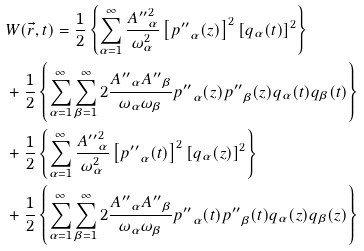<formula> <loc_0><loc_0><loc_500><loc_500>& W ( \vec { r } , t ) = \frac { 1 } { 2 } \left \{ \sum _ { \alpha = 1 } ^ { \infty } \frac { { A ^ { \prime \prime } } _ { \alpha } ^ { 2 } } { \omega _ { \alpha } ^ { 2 } } \left [ { p ^ { \prime \prime } } _ { \alpha } ( z ) \right ] ^ { 2 } \left [ q _ { \alpha } ( t ) \right ] ^ { 2 } \right \} \\ & + \frac { 1 } { 2 } \left \{ \sum _ { \alpha = 1 } ^ { \infty } \sum _ { \beta = 1 } ^ { \infty } 2 \frac { { A ^ { \prime \prime } } _ { \alpha } { A ^ { \prime \prime } } _ { \beta } } { \omega _ { \alpha } \omega _ { \beta } } { p ^ { \prime \prime } } _ { \alpha } ( z ) { p ^ { \prime \prime } } _ { \beta } ( z ) q _ { \alpha } ( t ) q _ { \beta } ( t ) \right \} \\ & + \frac { 1 } { 2 } \left \{ \sum _ { \alpha = 1 } ^ { \infty } \frac { { A ^ { \prime \prime } } _ { \alpha } ^ { 2 } } { \omega _ { \alpha } ^ { 2 } } \left [ { p ^ { \prime \prime } } _ { \alpha } ( t ) \right ] ^ { 2 } \left [ q _ { \alpha } ( z ) \right ] ^ { 2 } \right \} \\ & + \frac { 1 } { 2 } \left \{ \sum _ { \alpha = 1 } ^ { \infty } \sum _ { \beta = 1 } ^ { \infty } 2 \frac { { A ^ { \prime \prime } } _ { \alpha } { A ^ { \prime \prime } } _ { \beta } } { \omega _ { \alpha } \omega _ { \beta } } { p ^ { \prime \prime } } _ { \alpha } ( t ) { p ^ { \prime \prime } } _ { \beta } ( t ) q _ { \alpha } ( z ) q _ { \beta } ( z ) \right \}</formula> 